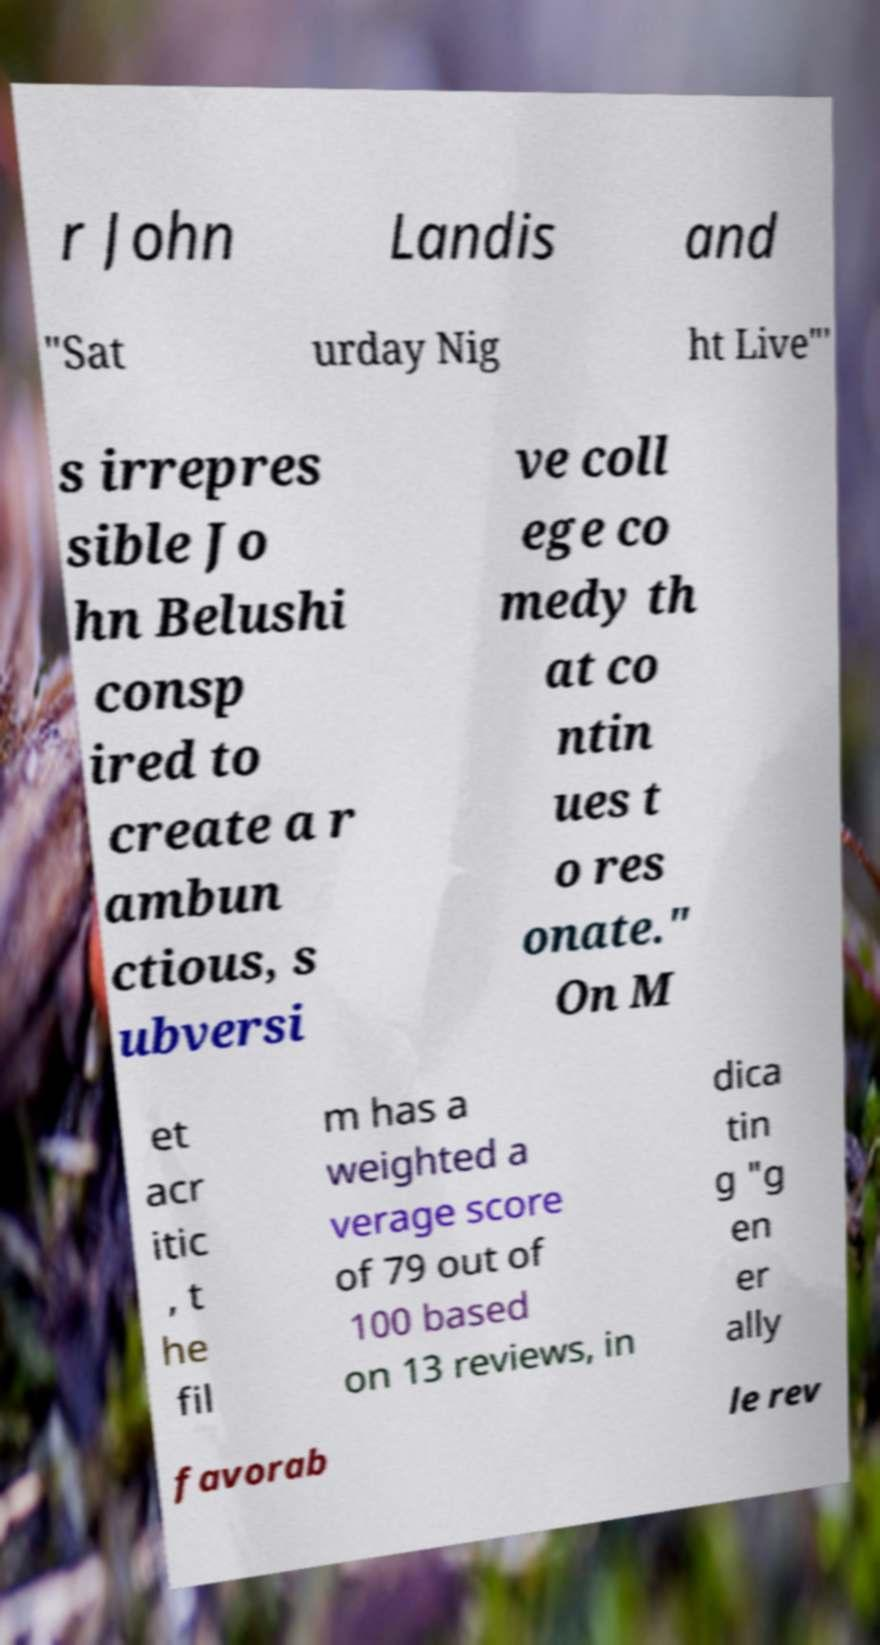Please read and relay the text visible in this image. What does it say? r John Landis and "Sat urday Nig ht Live"' s irrepres sible Jo hn Belushi consp ired to create a r ambun ctious, s ubversi ve coll ege co medy th at co ntin ues t o res onate." On M et acr itic , t he fil m has a weighted a verage score of 79 out of 100 based on 13 reviews, in dica tin g "g en er ally favorab le rev 